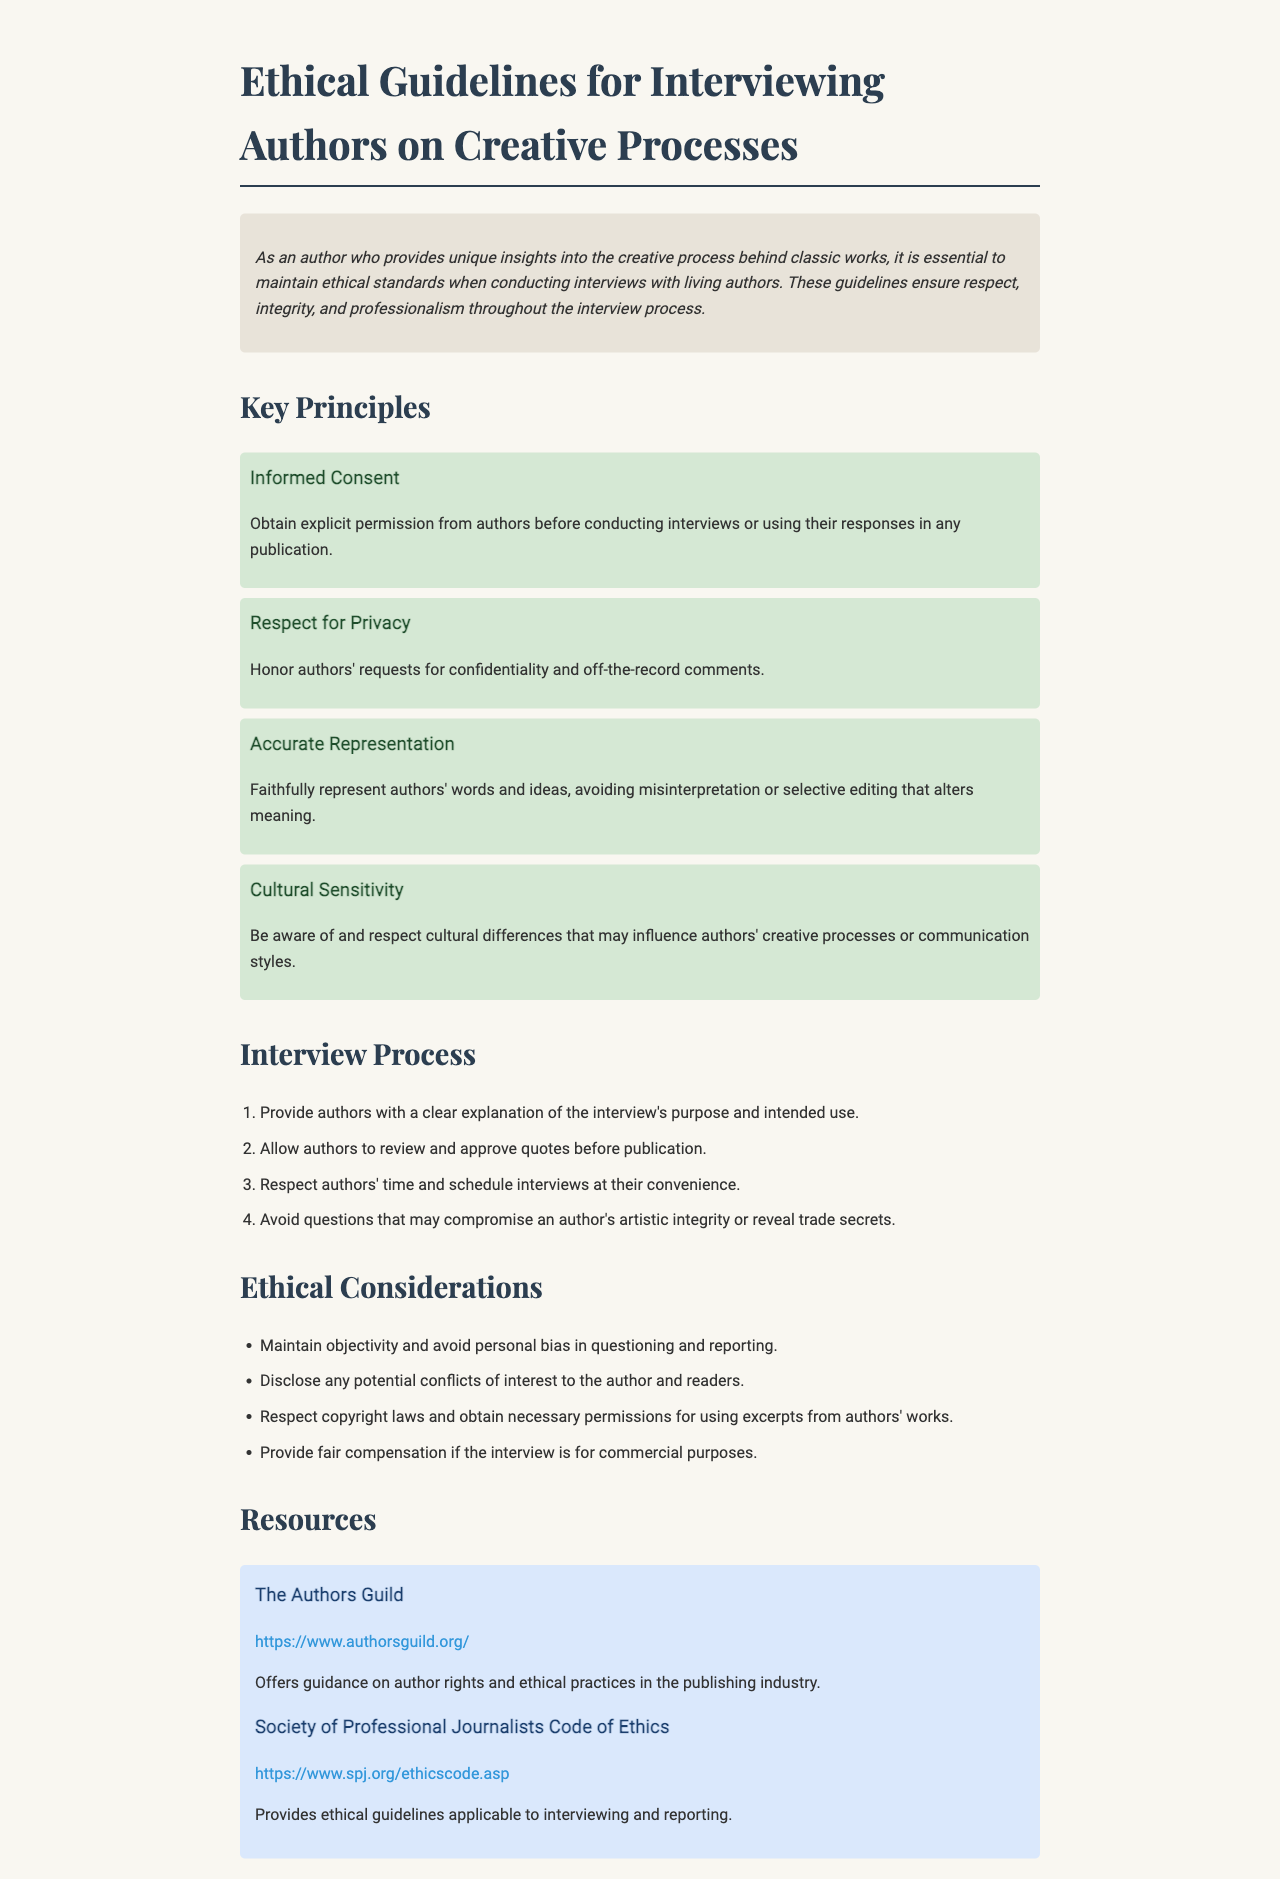What are the key principles of ethical guidelines? The document lists four key principles regarding ethical guidelines for interviewing authors, which include informed consent, respect for privacy, accurate representation, and cultural sensitivity.
Answer: four What does the principle of informed consent entail? This principle stresses the importance of obtaining explicit permission from authors before conducting interviews or using their responses in any publication.
Answer: explicit permission How many steps are outlined in the interview process? The document enumerates four distinct steps to follow during the interview process with authors.
Answer: four What should authors be allowed to do before publication? The guidelines specify that authors should have the opportunity to review and approve quotes before they are published.
Answer: review and approve Which organization provides guidance on author rights? The document references "The Authors Guild" as an organization that offers guidance on author rights and ethical practices in the publishing industry.
Answer: The Authors Guild What is a key ethical consideration regarding objectivity? The document emphasizes the need to maintain objectivity and avoid personal bias when questioning and reporting during interviews.
Answer: objectivity What should be disclosed to the author and readers? The document mentions that any potential conflicts of interest need to be disclosed to both the author and the readers.
Answer: conflicts of interest How is copyright addressed in the ethical guidelines? The guidelines state that it is important to respect copyright laws and obtain necessary permissions for using excerpts from authors' works.
Answer: respect copyright laws What should be respected concerning an author's comments? The guidelines instruct interviewers to honor authors' requests for confidentiality and off-the-record comments.
Answer: confidentiality 